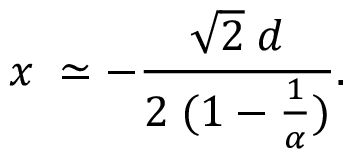Convert formula to latex. <formula><loc_0><loc_0><loc_500><loc_500>x \, \simeq - \frac { \sqrt { 2 } \, d } { 2 \, ( 1 - \frac { 1 } { \alpha } ) } .</formula> 